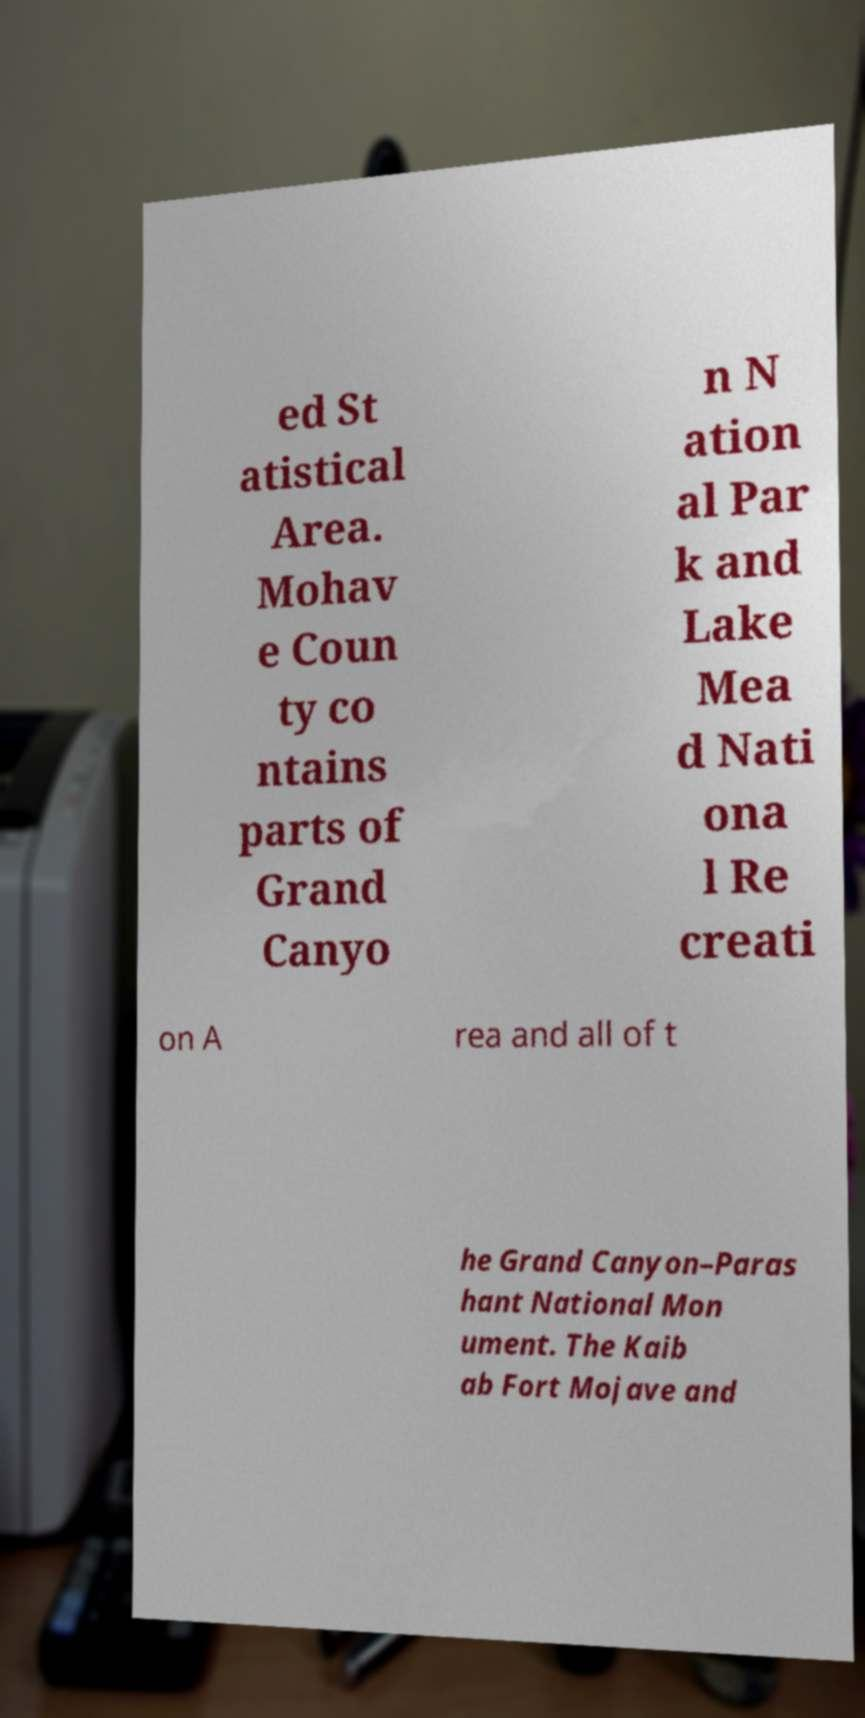Can you read and provide the text displayed in the image?This photo seems to have some interesting text. Can you extract and type it out for me? ed St atistical Area. Mohav e Coun ty co ntains parts of Grand Canyo n N ation al Par k and Lake Mea d Nati ona l Re creati on A rea and all of t he Grand Canyon–Paras hant National Mon ument. The Kaib ab Fort Mojave and 